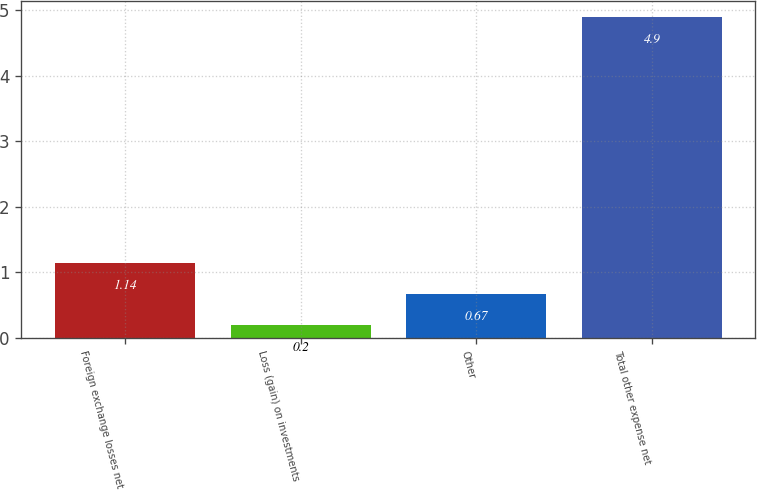Convert chart to OTSL. <chart><loc_0><loc_0><loc_500><loc_500><bar_chart><fcel>Foreign exchange losses net<fcel>Loss (gain) on investments<fcel>Other<fcel>Total other expense net<nl><fcel>1.14<fcel>0.2<fcel>0.67<fcel>4.9<nl></chart> 